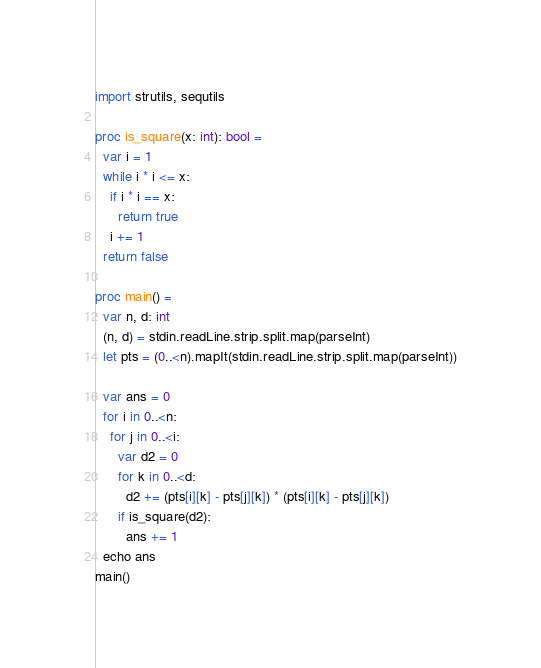Convert code to text. <code><loc_0><loc_0><loc_500><loc_500><_Nim_>import strutils, sequtils

proc is_square(x: int): bool =
  var i = 1
  while i * i <= x:
    if i * i == x:
      return true
    i += 1
  return false

proc main() =
  var n, d: int
  (n, d) = stdin.readLine.strip.split.map(parseInt)
  let pts = (0..<n).mapIt(stdin.readLine.strip.split.map(parseInt))

  var ans = 0
  for i in 0..<n:
    for j in 0..<i:
      var d2 = 0
      for k in 0..<d:
        d2 += (pts[i][k] - pts[j][k]) * (pts[i][k] - pts[j][k])
      if is_square(d2):
        ans += 1
  echo ans
main()
</code> 